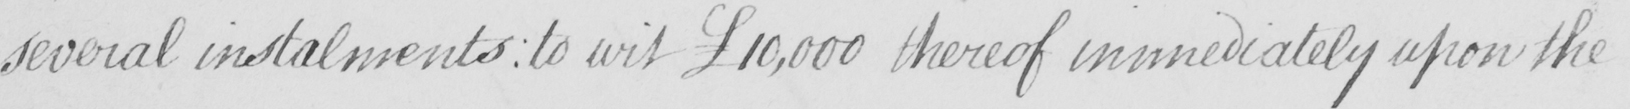Please transcribe the handwritten text in this image. several instalments  :  to wit £10,000 thereof immediately upon the 